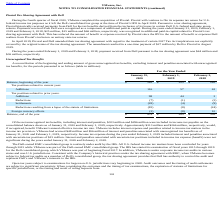From Vmware's financial document, Which years does the table provide information for a reconciliation of the beginning and ending amount of gross unrecognized tax benefits, excluding interest and penalties associated with unrecognized tax benefits? The document contains multiple relevant values: 2020, 2019, 2018. From the document: "ing the years ended January 31, 2020, February 1, 2019 and February 2, 2018, $25 million, $15 million and $66 million, respectively, was recognized in..." Also, What were the additions to tax positions related to current year in 2020? According to the financial document, 116 (in millions). The relevant text states: "Additions 116 57 63..." Also, What were the settlements for tax positions related to prior years in 2019? According to the financial document, (4) (in millions). The relevant text states: "Settlements (28) (4) (9)..." Also, can you calculate: What was the change in the balance at the beginning of the year between 2019 and 2020? Based on the calculation: 385-305, the result is 80 (in millions). This is based on the information: "Balance, beginning of the year $ 385 $ 305 $ 265 Balance, beginning of the year $ 385 $ 305 $ 265..." The key data points involved are: 305, 385. Also, How many years did additions to tax positions related to prior years exceed $50 million? Based on the analysis, there are 1 instances. The counting process: 2020. Also, can you calculate: What was the percentage change in the balance at the end of the year between 2019 and 2020? To answer this question, I need to perform calculations using the financial data. The calculation is: (479-385)/385, which equals 24.42 (percentage). This is based on the information: "Balance, beginning of the year $ 385 $ 305 $ 265 Balance, end of the year $ 479 $ 385 $ 305..." The key data points involved are: 385, 479. 